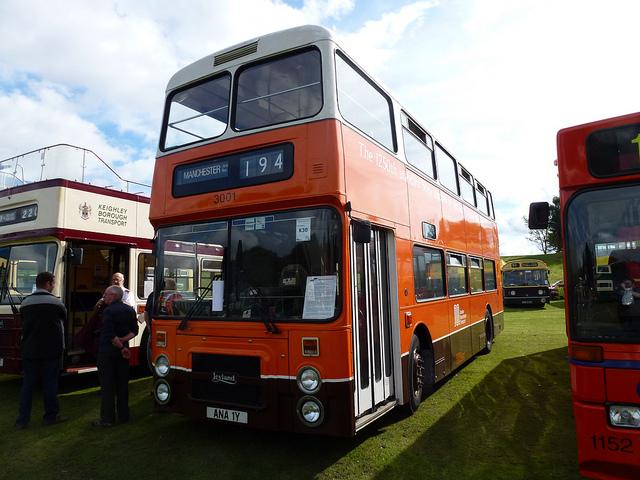What number is on the bus in the middle? Please explain your reasoning. 194. The bus number is 194. 